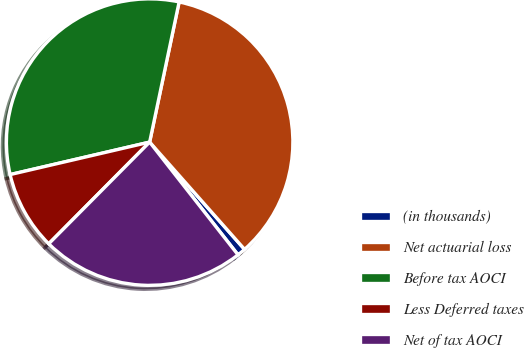Convert chart. <chart><loc_0><loc_0><loc_500><loc_500><pie_chart><fcel>(in thousands)<fcel>Net actuarial loss<fcel>Before tax AOCI<fcel>Less Deferred taxes<fcel>Net of tax AOCI<nl><fcel>0.95%<fcel>35.17%<fcel>31.94%<fcel>8.92%<fcel>23.02%<nl></chart> 